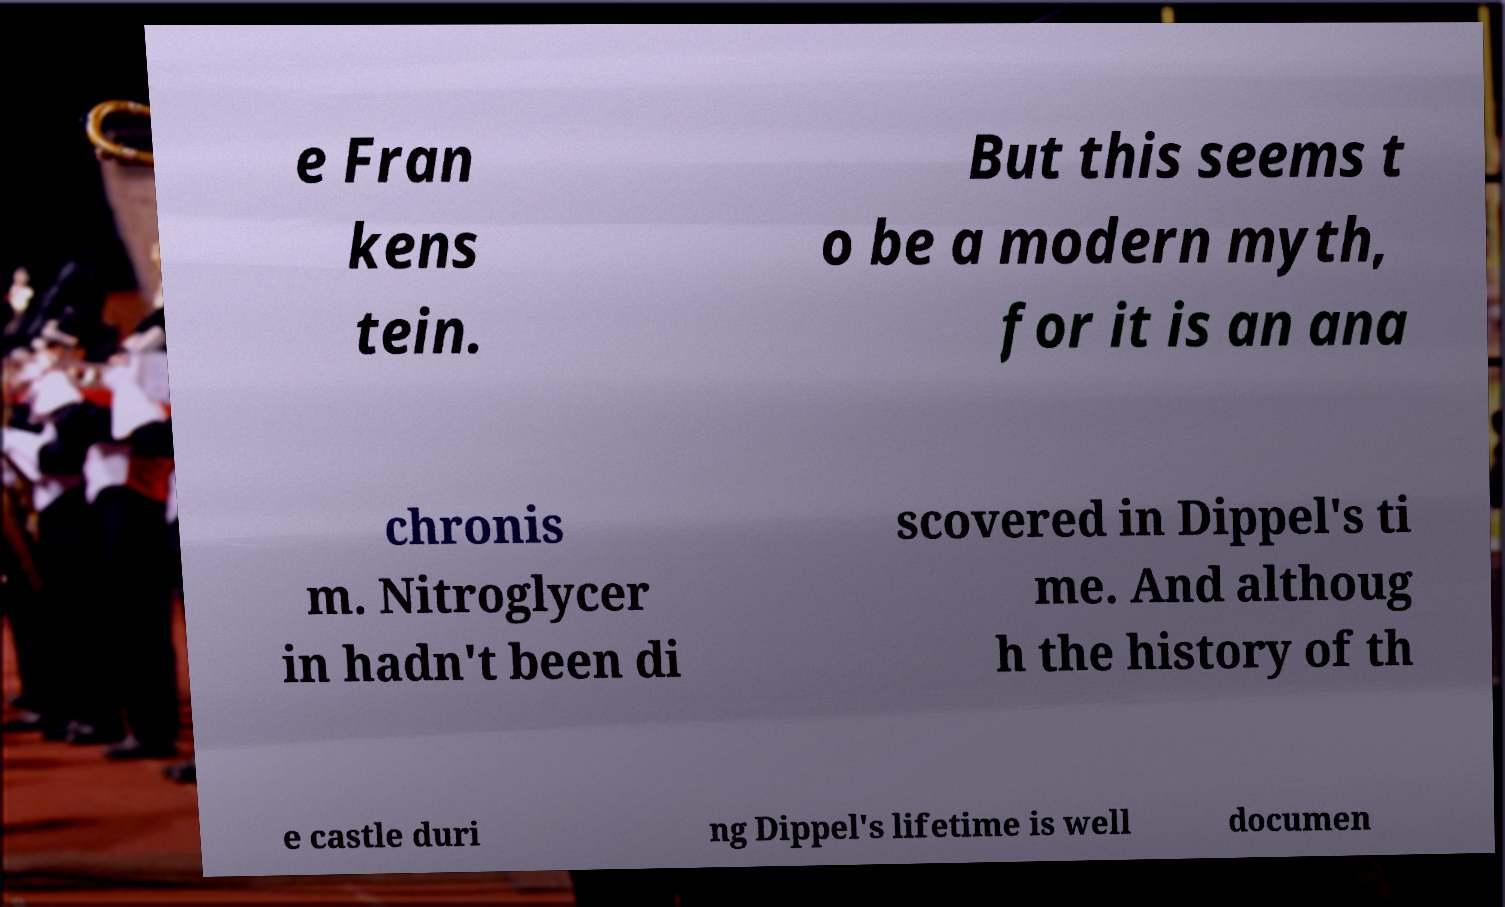Can you read and provide the text displayed in the image?This photo seems to have some interesting text. Can you extract and type it out for me? e Fran kens tein. But this seems t o be a modern myth, for it is an ana chronis m. Nitroglycer in hadn't been di scovered in Dippel's ti me. And althoug h the history of th e castle duri ng Dippel's lifetime is well documen 